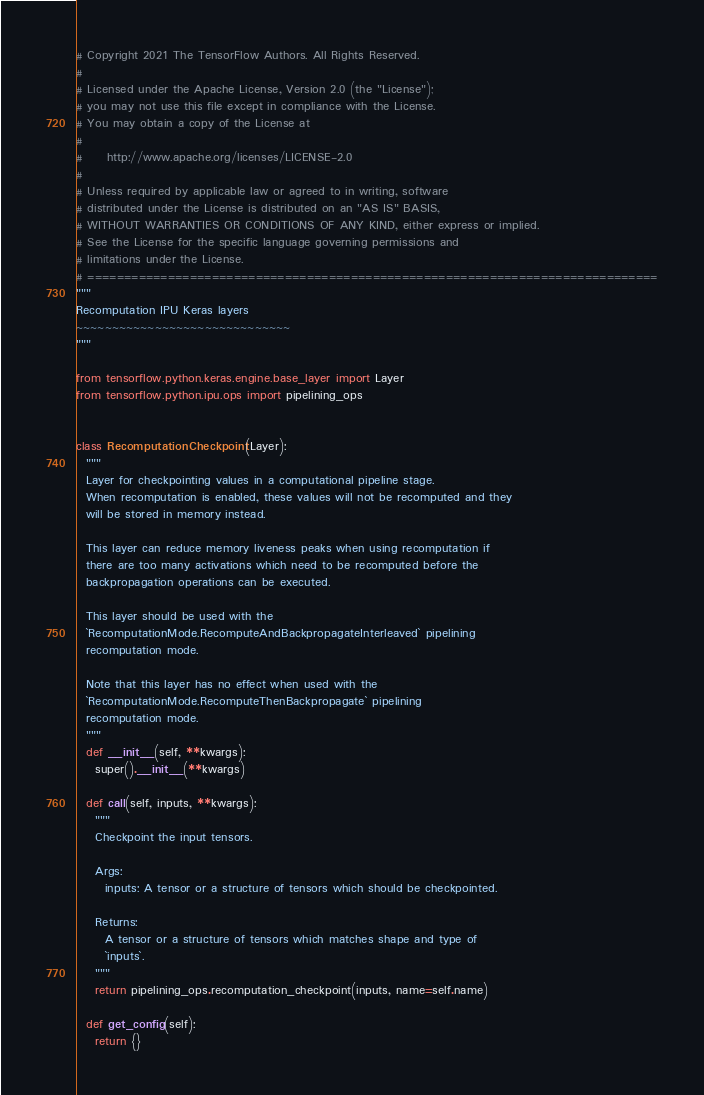<code> <loc_0><loc_0><loc_500><loc_500><_Python_># Copyright 2021 The TensorFlow Authors. All Rights Reserved.
#
# Licensed under the Apache License, Version 2.0 (the "License");
# you may not use this file except in compliance with the License.
# You may obtain a copy of the License at
#
#     http://www.apache.org/licenses/LICENSE-2.0
#
# Unless required by applicable law or agreed to in writing, software
# distributed under the License is distributed on an "AS IS" BASIS,
# WITHOUT WARRANTIES OR CONDITIONS OF ANY KIND, either express or implied.
# See the License for the specific language governing permissions and
# limitations under the License.
# ==============================================================================
"""
Recomputation IPU Keras layers
~~~~~~~~~~~~~~~~~~~~~~~~~~~~~~
"""

from tensorflow.python.keras.engine.base_layer import Layer
from tensorflow.python.ipu.ops import pipelining_ops


class RecomputationCheckpoint(Layer):
  """
  Layer for checkpointing values in a computational pipeline stage.
  When recomputation is enabled, these values will not be recomputed and they
  will be stored in memory instead.

  This layer can reduce memory liveness peaks when using recomputation if
  there are too many activations which need to be recomputed before the
  backpropagation operations can be executed.

  This layer should be used with the
  `RecomputationMode.RecomputeAndBackpropagateInterleaved` pipelining
  recomputation mode.

  Note that this layer has no effect when used with the
  `RecomputationMode.RecomputeThenBackpropagate` pipelining
  recomputation mode.
  """
  def __init__(self, **kwargs):
    super().__init__(**kwargs)

  def call(self, inputs, **kwargs):
    """
    Checkpoint the input tensors.

    Args:
      inputs: A tensor or a structure of tensors which should be checkpointed.

    Returns:
      A tensor or a structure of tensors which matches shape and type of
      `inputs`.
    """
    return pipelining_ops.recomputation_checkpoint(inputs, name=self.name)

  def get_config(self):
    return {}
</code> 